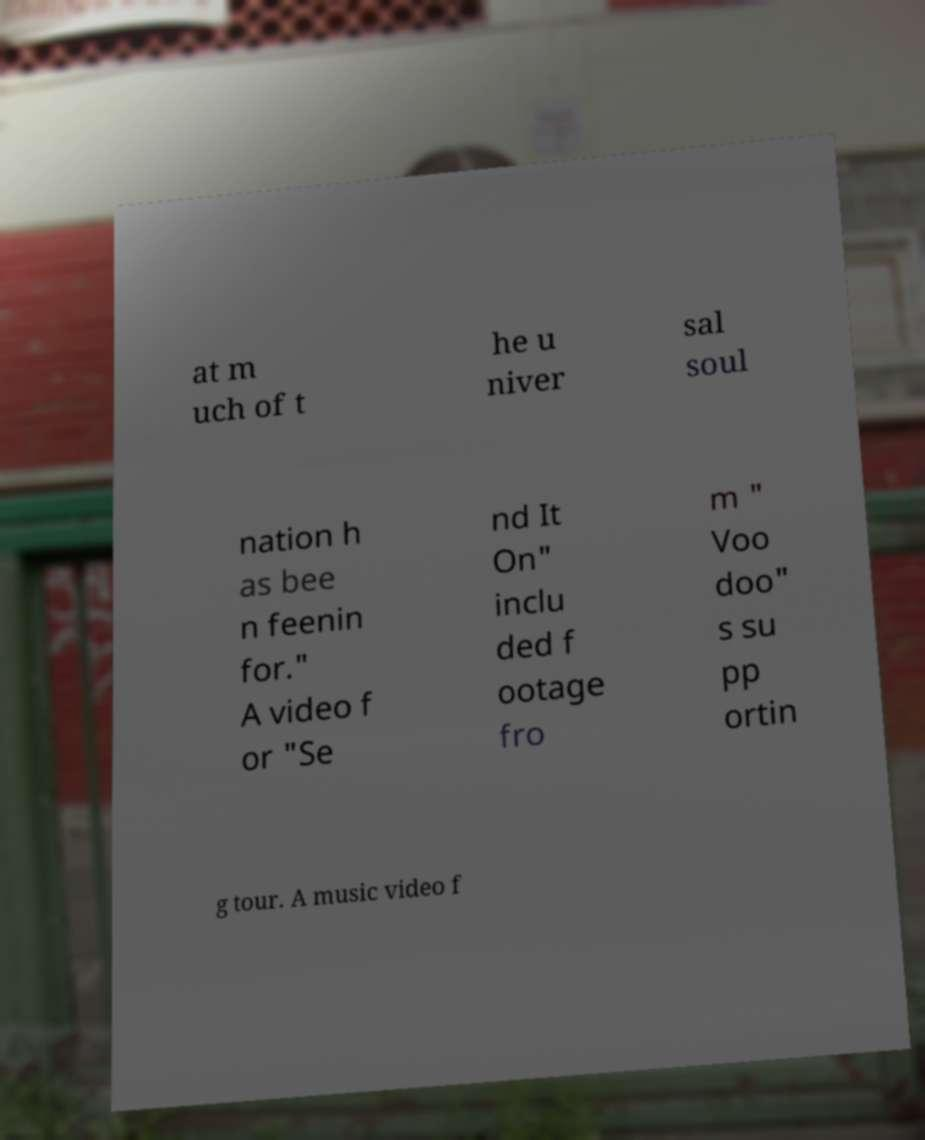For documentation purposes, I need the text within this image transcribed. Could you provide that? at m uch of t he u niver sal soul nation h as bee n feenin for." A video f or "Se nd It On" inclu ded f ootage fro m " Voo doo" s su pp ortin g tour. A music video f 